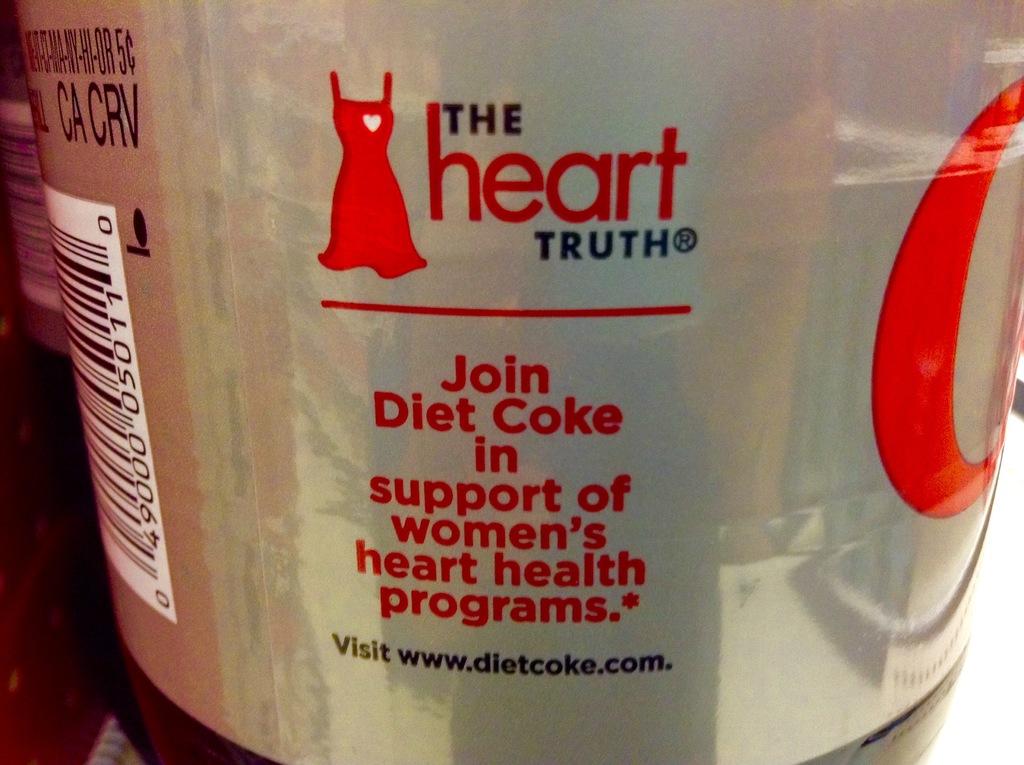What type of drink is this?
Make the answer very short. Diet coke. 